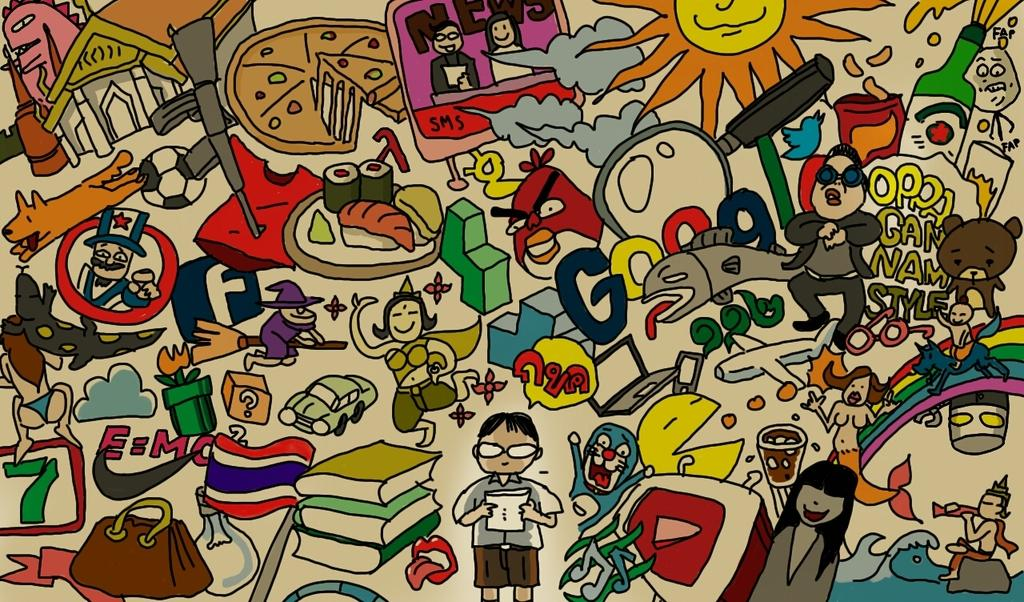What type of visual is the image? The image is a poster. What kind of characters are featured in the poster? There are many cartoons in the poster. Is there any text present on the poster? Yes, there is text written on the poster. What other objects can be seen in the poster? There are books depicted in the poster. Can you see the maid cleaning the books in the poster? There is no maid present in the poster, and the books are not being cleaned. 